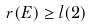<formula> <loc_0><loc_0><loc_500><loc_500>r ( E ) \geq l ( 2 )</formula> 